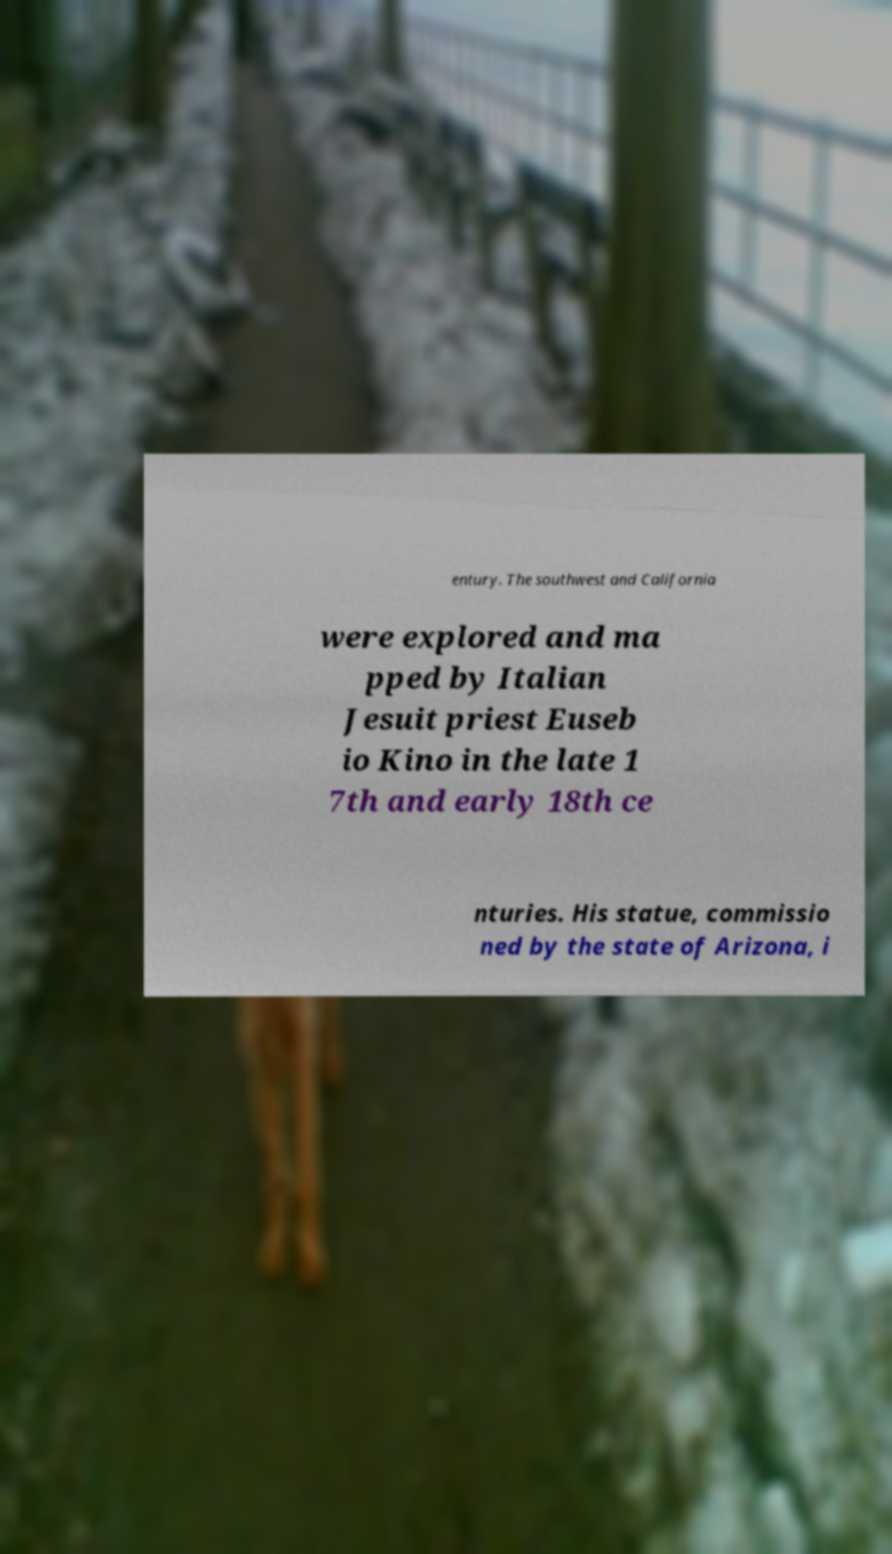Can you read and provide the text displayed in the image?This photo seems to have some interesting text. Can you extract and type it out for me? entury. The southwest and California were explored and ma pped by Italian Jesuit priest Euseb io Kino in the late 1 7th and early 18th ce nturies. His statue, commissio ned by the state of Arizona, i 